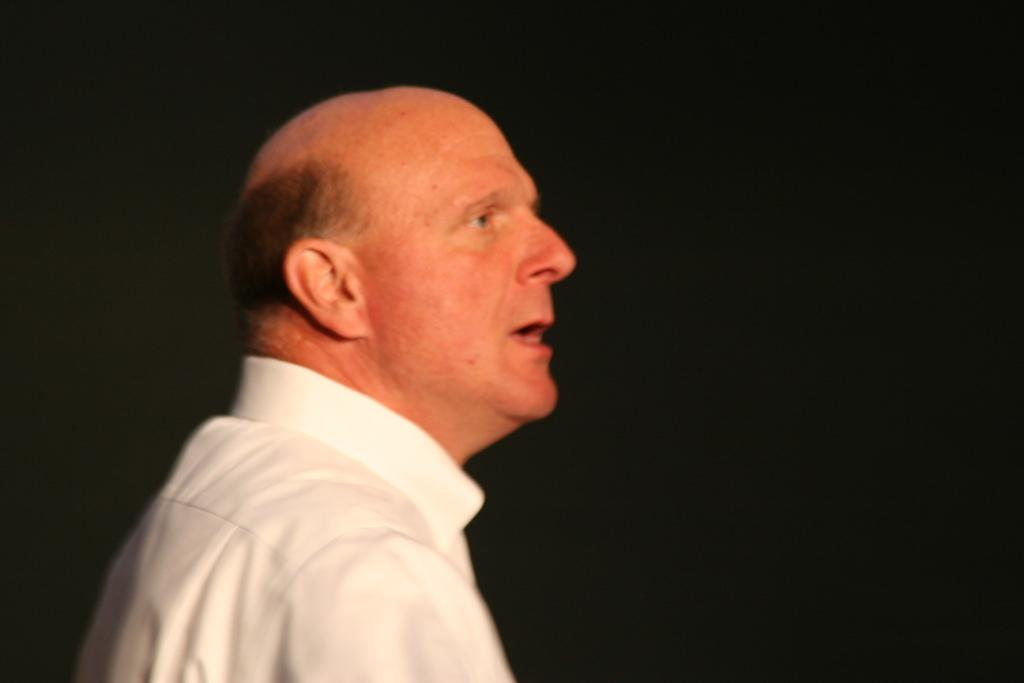Who or what is the main subject in the image? There is a person in the image. What can be observed about the background of the image? The background of the image is dark. What type of blade is being used by the person in the image? There is no blade visible in the image, as the focus is on the person and the dark background. 